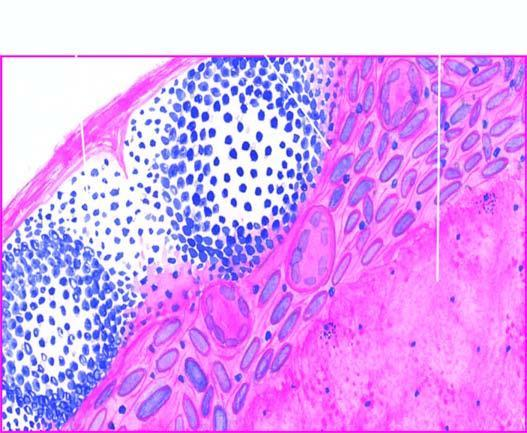what shows granulomatous inflammation?
Answer the question using a single word or phrase. The periphery inflammation 